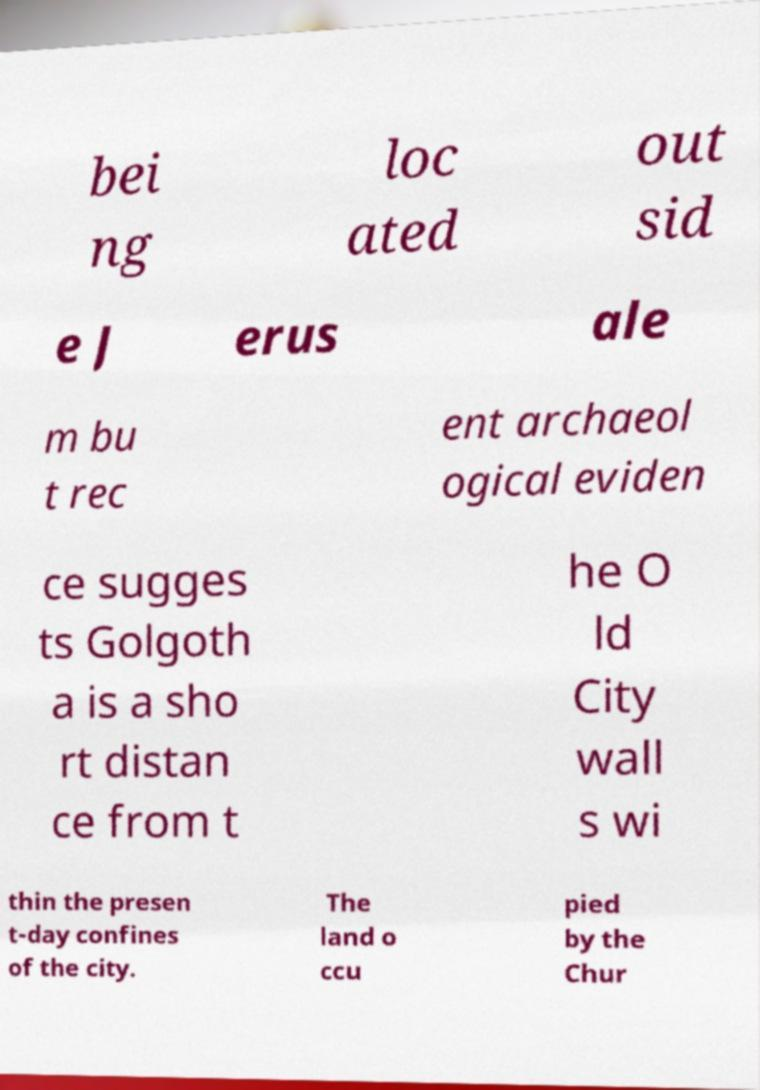Please identify and transcribe the text found in this image. bei ng loc ated out sid e J erus ale m bu t rec ent archaeol ogical eviden ce sugges ts Golgoth a is a sho rt distan ce from t he O ld City wall s wi thin the presen t-day confines of the city. The land o ccu pied by the Chur 